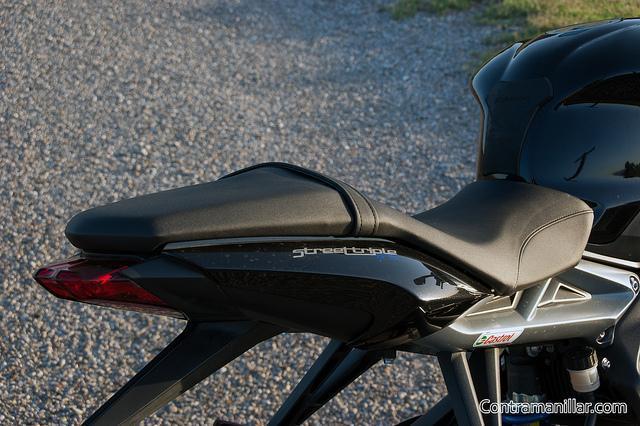How many motorcycles are visible?
Give a very brief answer. 1. 